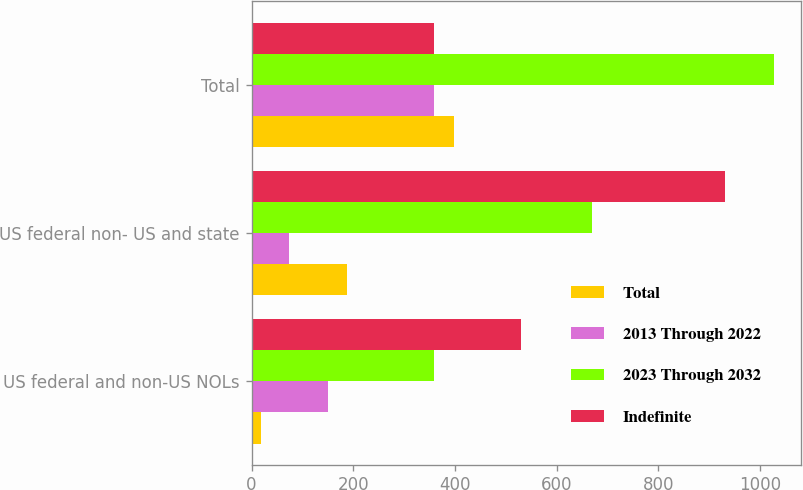Convert chart to OTSL. <chart><loc_0><loc_0><loc_500><loc_500><stacked_bar_chart><ecel><fcel>US federal and non-US NOLs<fcel>US federal non- US and state<fcel>Total<nl><fcel>Total<fcel>19<fcel>188<fcel>398<nl><fcel>2013 Through 2022<fcel>151<fcel>74<fcel>358<nl><fcel>2023 Through 2032<fcel>359<fcel>669<fcel>1028<nl><fcel>Indefinite<fcel>529<fcel>931<fcel>359<nl></chart> 